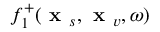Convert formula to latex. <formula><loc_0><loc_0><loc_500><loc_500>f _ { 1 } ^ { + } ( x _ { s } , x _ { v } , \omega )</formula> 